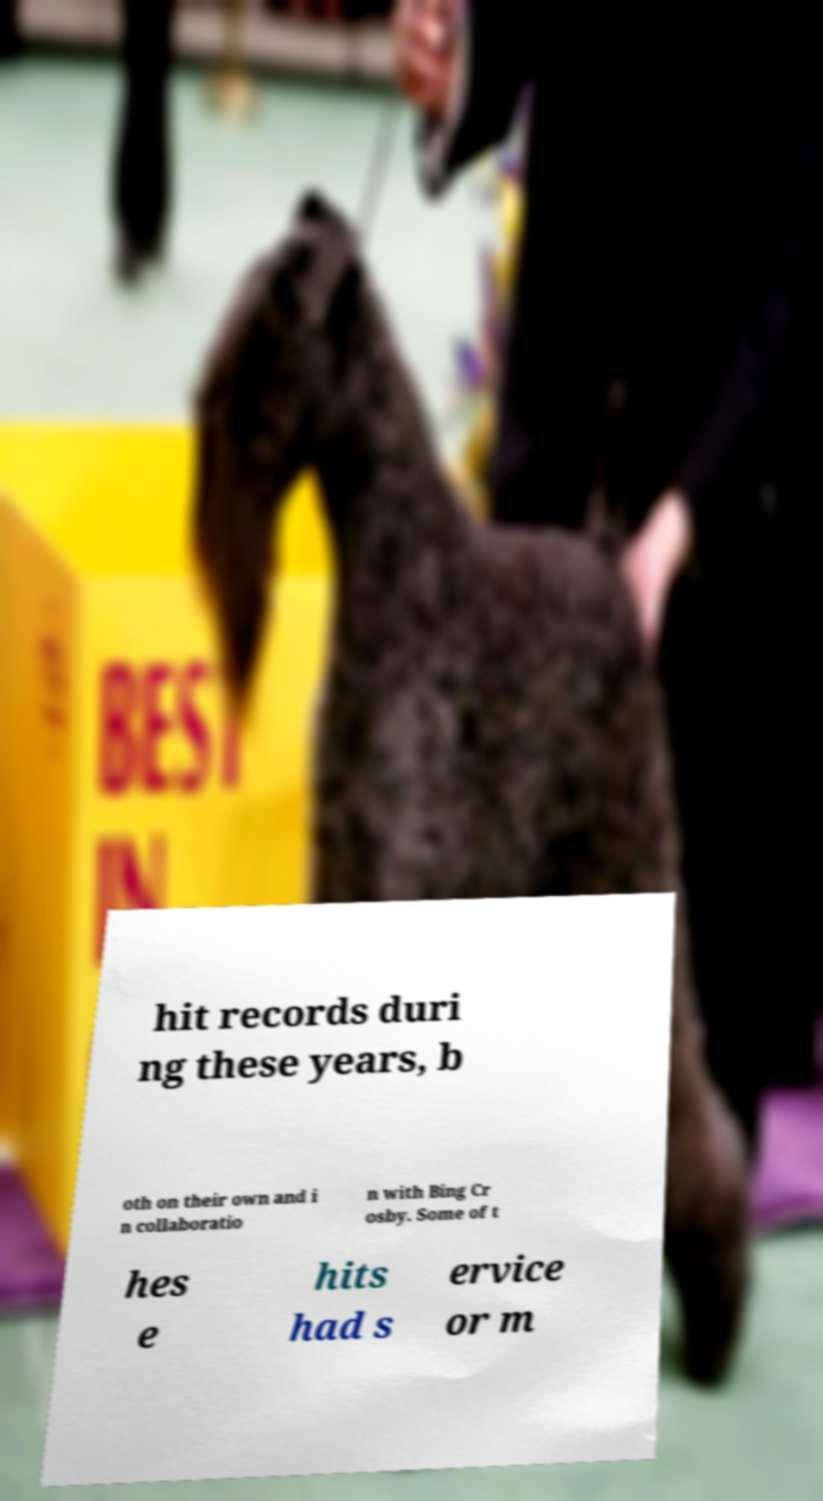What messages or text are displayed in this image? I need them in a readable, typed format. hit records duri ng these years, b oth on their own and i n collaboratio n with Bing Cr osby. Some of t hes e hits had s ervice or m 